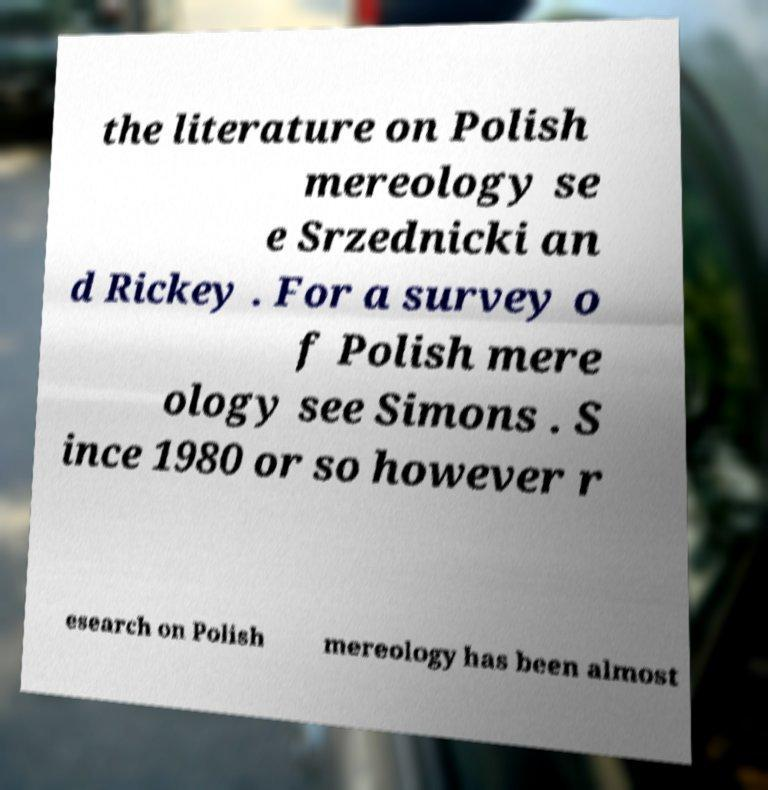Could you assist in decoding the text presented in this image and type it out clearly? the literature on Polish mereology se e Srzednicki an d Rickey . For a survey o f Polish mere ology see Simons . S ince 1980 or so however r esearch on Polish mereology has been almost 